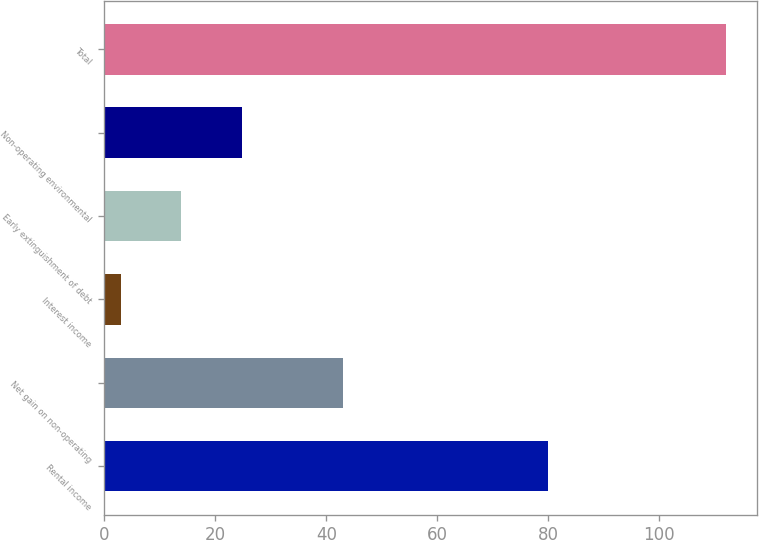Convert chart to OTSL. <chart><loc_0><loc_0><loc_500><loc_500><bar_chart><fcel>Rental income<fcel>Net gain on non-operating<fcel>Interest income<fcel>Early extinguishment of debt<fcel>Non-operating environmental<fcel>Total<nl><fcel>80<fcel>43<fcel>3<fcel>13.9<fcel>24.8<fcel>112<nl></chart> 